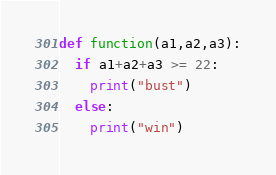Convert code to text. <code><loc_0><loc_0><loc_500><loc_500><_Python_>def function(a1,a2,a3):
  if a1+a2+a3 >= 22:
    print("bust")
  else:
    print("win")</code> 